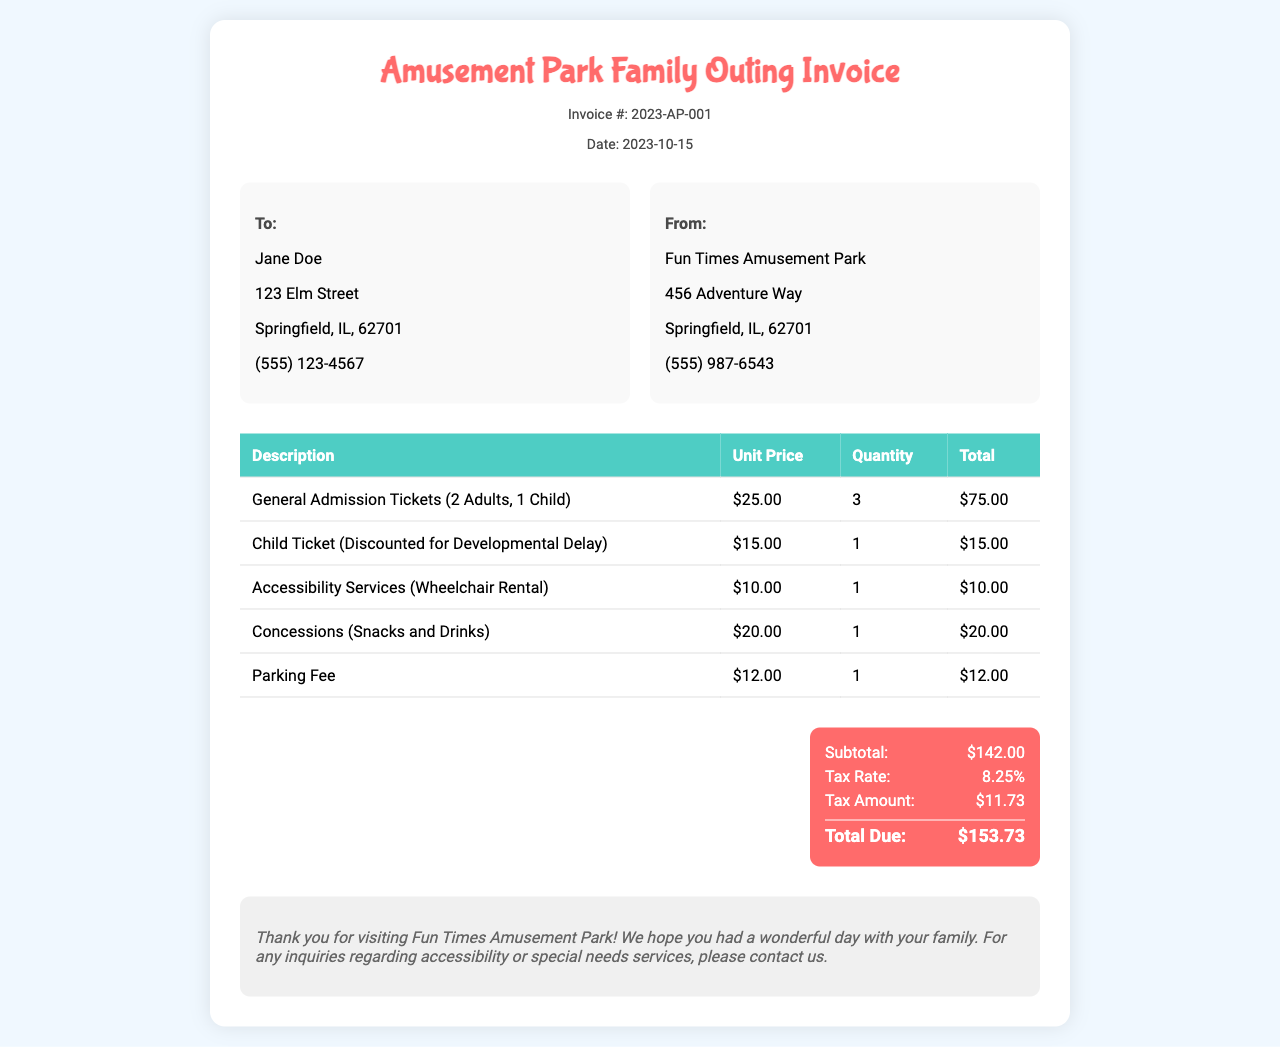What is the invoice number? The invoice number is specifically stated in the document title section, which is a unique identifier for this invoice.
Answer: 2023-AP-001 What is the date of the invoice? The date is mentioned right below the invoice number, indicating when the invoice was issued.
Answer: 2023-10-15 Who is the invoice addressed to? The name of the individual receiving the services or being billed is listed in the "To" section of the document.
Answer: Jane Doe How many general admission tickets were purchased? This information can be found in the itemized list of tickets, detailing quantities purchased.
Answer: 3 What was the total due amount? The total due is summarized at the end of the invoice, reflecting the final amount payable by the customer.
Answer: $153.73 What type of ticket had a discounted price? A specific ticket is noted for its reduced price due to developmental delays, highlighting a service catering to special needs.
Answer: Child Ticket (Discounted for Developmental Delay) What is the tax rate applied to the invoice? This information is noted in the summary section, indicating the percentage applied to the subtotal for tax calculations.
Answer: 8.25% How much was spent on concessions? The amount spent on concessions is detailed in the itemized table of expenses.
Answer: $20.00 What was the purpose of the wheelchair rental charge? The wheelchair rental is specifically mentioned as an accessibility service, which assists guests with mobility challenges.
Answer: Accessibility Services (Wheelchair Rental) 